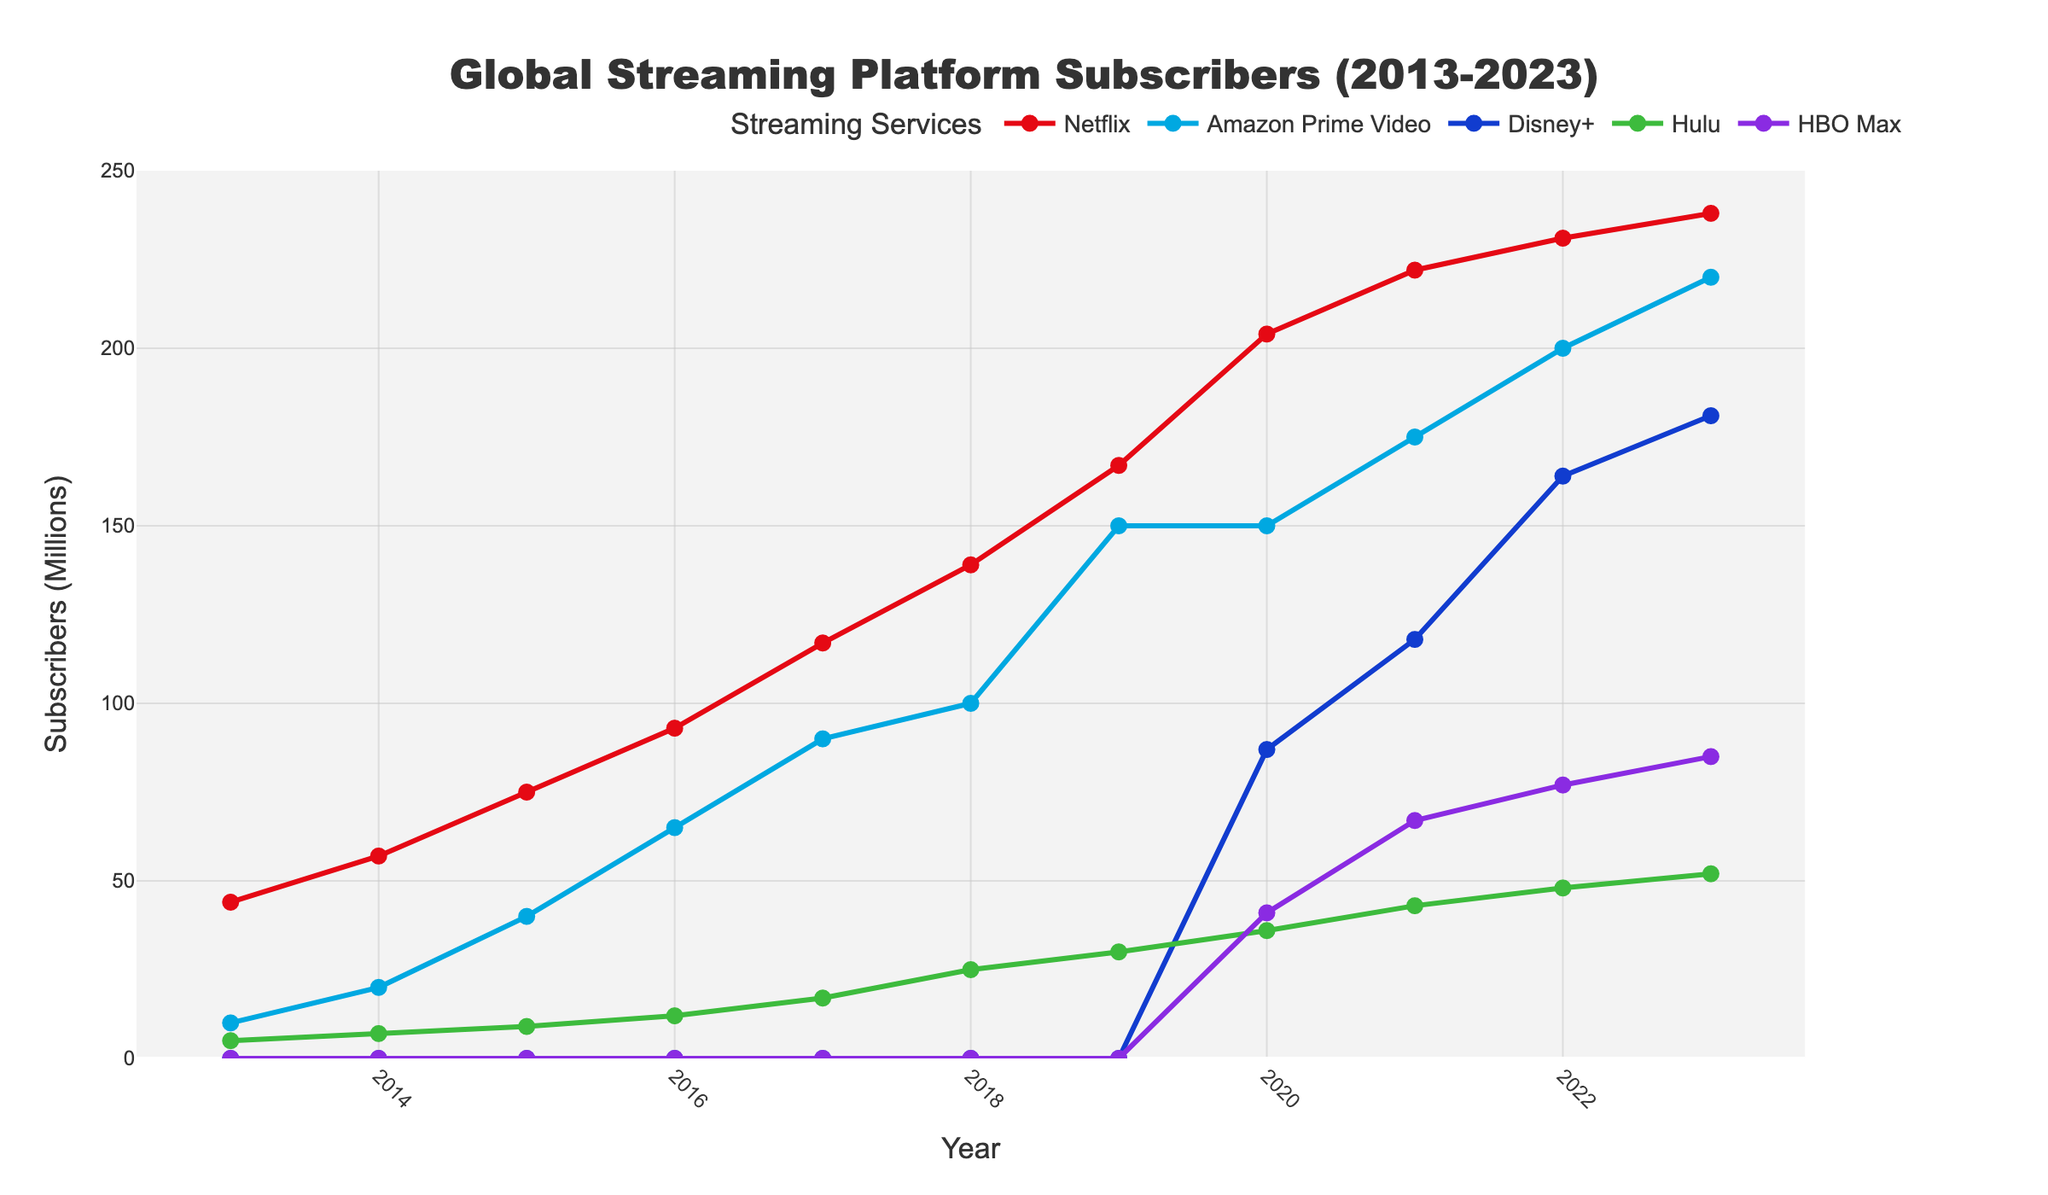What's the largest gain in subscribers for Netflix over a single year? Look at the differences in subscriber numbers for Netflix from year to year. The largest gain is from 2018 to 2019, where the numbers increase from 139 million to 167 million. This is an increase of 167 - 139 = 28 million.
Answer: 28 million Which streaming service had zero subscribers in 2016, but a significant number by 2023? Disney+ had zero subscribers in 2016 and grew to 181 million subscribers by 2023.
Answer: Disney+ In what year did Amazon Prime Video have exactly half the number of subscribers as Netflix? Look at the years and compare the subscriber numbers of Amazon Prime Video to half of Netflix's numbers. In 2017, Amazon Prime Video had 90 million, which is half of Netflix's 180 million subscribers.
Answer: 2017 Between which two consecutive years did Hulu see the largest increase in subscribers? Compare the subscriber differences between consecutive years for Hulu. The largest increase is between 2016 (12 million) and 2017 (17 million), a gain of 5 million.
Answer: 2016 to 2017 What is the total number of subscribers for all services combined in 2023? Sum the number of subscribers for all services in 2023: 238 (Netflix) + 220 (Amazon Prime Video) + 181 (Disney+) + 52 (Hulu) + 85 (HBO Max) = 776 million.
Answer: 776 million Which streaming service surpassed 100 million subscribers first, and in which year did this happen? Netflix surpassed 100 million subscribers first, achieving 117 million subscribers in 2017.
Answer: Netflix, 2017 Is there any year where both Netflix and Disney+ increased their subscribers by over 20 million from the previous year? Check the subscriber differences year by year for both Netflix and Disney+. Both saw increases over 20 million in different years, but not in the same year.
Answer: No Which year had the smallest disparity in subscriber numbers between Hulu and HBO Max? Calculate the differences year by year and find the smallest difference. In 2023, the subscriber difference is smallest at 33 million (Hulu: 52, HBO Max: 85).
Answer: 2023 What is the average number of subscribers for Disney+ across all years it is shown in the data? Sum up the subscribers for Disney+ from 2020 to 2023, then divide by the number of years: (87 + 118 + 164 + 181) / 4 = 137.5 million.
Answer: 137.5 million Between Netflix and Amazon Prime Video, which service had a more consistent growth pattern in subscribers? Compare the year-over-year changes in subscribers for both Netflix and Amazon Prime Video. Netflix shows a more consistent annual increase without sharp fluctuations.
Answer: Netflix 